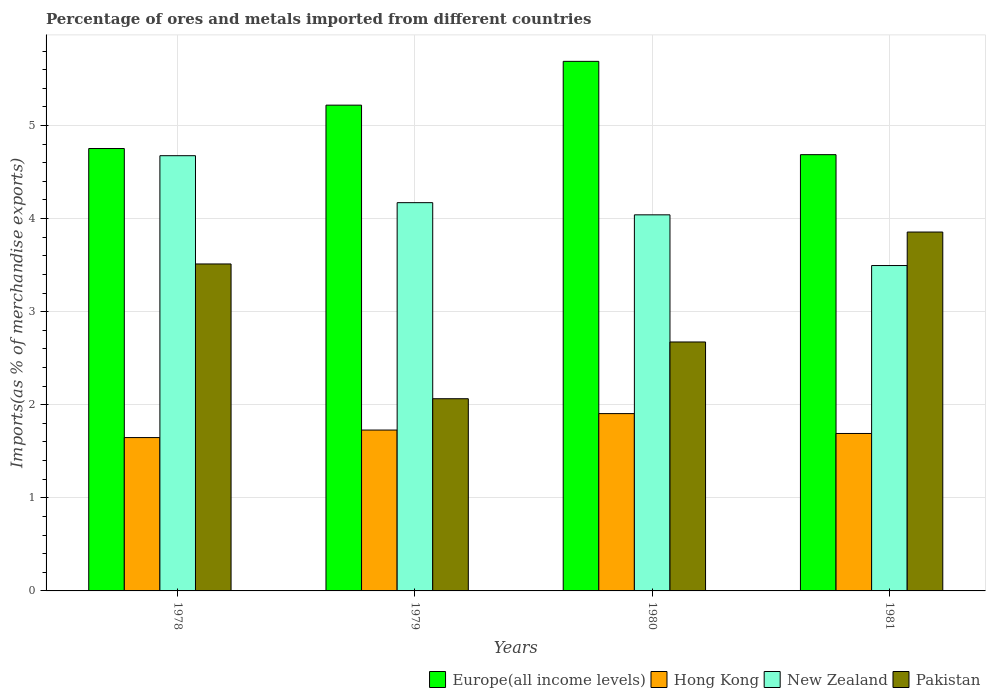How many different coloured bars are there?
Provide a succinct answer. 4. Are the number of bars per tick equal to the number of legend labels?
Keep it short and to the point. Yes. Are the number of bars on each tick of the X-axis equal?
Offer a very short reply. Yes. How many bars are there on the 2nd tick from the left?
Keep it short and to the point. 4. How many bars are there on the 4th tick from the right?
Keep it short and to the point. 4. What is the label of the 3rd group of bars from the left?
Offer a very short reply. 1980. In how many cases, is the number of bars for a given year not equal to the number of legend labels?
Ensure brevity in your answer.  0. What is the percentage of imports to different countries in Europe(all income levels) in 1981?
Your answer should be compact. 4.69. Across all years, what is the maximum percentage of imports to different countries in New Zealand?
Make the answer very short. 4.68. Across all years, what is the minimum percentage of imports to different countries in Pakistan?
Your answer should be very brief. 2.06. In which year was the percentage of imports to different countries in Europe(all income levels) maximum?
Offer a terse response. 1980. In which year was the percentage of imports to different countries in New Zealand minimum?
Offer a terse response. 1981. What is the total percentage of imports to different countries in New Zealand in the graph?
Provide a succinct answer. 16.38. What is the difference between the percentage of imports to different countries in Pakistan in 1979 and that in 1980?
Offer a terse response. -0.61. What is the difference between the percentage of imports to different countries in Europe(all income levels) in 1978 and the percentage of imports to different countries in Hong Kong in 1980?
Provide a short and direct response. 2.85. What is the average percentage of imports to different countries in New Zealand per year?
Keep it short and to the point. 4.1. In the year 1980, what is the difference between the percentage of imports to different countries in Europe(all income levels) and percentage of imports to different countries in Pakistan?
Your answer should be compact. 3.01. In how many years, is the percentage of imports to different countries in Pakistan greater than 5.2 %?
Your answer should be very brief. 0. What is the ratio of the percentage of imports to different countries in Europe(all income levels) in 1979 to that in 1980?
Offer a terse response. 0.92. Is the difference between the percentage of imports to different countries in Europe(all income levels) in 1979 and 1981 greater than the difference between the percentage of imports to different countries in Pakistan in 1979 and 1981?
Give a very brief answer. Yes. What is the difference between the highest and the second highest percentage of imports to different countries in Pakistan?
Provide a short and direct response. 0.34. What is the difference between the highest and the lowest percentage of imports to different countries in Hong Kong?
Your answer should be compact. 0.26. Is the sum of the percentage of imports to different countries in Pakistan in 1978 and 1979 greater than the maximum percentage of imports to different countries in New Zealand across all years?
Your response must be concise. Yes. Is it the case that in every year, the sum of the percentage of imports to different countries in Europe(all income levels) and percentage of imports to different countries in New Zealand is greater than the sum of percentage of imports to different countries in Pakistan and percentage of imports to different countries in Hong Kong?
Keep it short and to the point. Yes. What does the 3rd bar from the right in 1979 represents?
Offer a terse response. Hong Kong. How many bars are there?
Keep it short and to the point. 16. How many years are there in the graph?
Your response must be concise. 4. What is the difference between two consecutive major ticks on the Y-axis?
Keep it short and to the point. 1. Does the graph contain any zero values?
Provide a succinct answer. No. Where does the legend appear in the graph?
Your response must be concise. Bottom right. How are the legend labels stacked?
Ensure brevity in your answer.  Horizontal. What is the title of the graph?
Your response must be concise. Percentage of ores and metals imported from different countries. What is the label or title of the X-axis?
Provide a succinct answer. Years. What is the label or title of the Y-axis?
Offer a terse response. Imports(as % of merchandise exports). What is the Imports(as % of merchandise exports) of Europe(all income levels) in 1978?
Ensure brevity in your answer.  4.75. What is the Imports(as % of merchandise exports) of Hong Kong in 1978?
Offer a very short reply. 1.65. What is the Imports(as % of merchandise exports) of New Zealand in 1978?
Make the answer very short. 4.68. What is the Imports(as % of merchandise exports) of Pakistan in 1978?
Your answer should be very brief. 3.51. What is the Imports(as % of merchandise exports) of Europe(all income levels) in 1979?
Offer a very short reply. 5.22. What is the Imports(as % of merchandise exports) in Hong Kong in 1979?
Your response must be concise. 1.73. What is the Imports(as % of merchandise exports) of New Zealand in 1979?
Offer a terse response. 4.17. What is the Imports(as % of merchandise exports) in Pakistan in 1979?
Keep it short and to the point. 2.06. What is the Imports(as % of merchandise exports) in Europe(all income levels) in 1980?
Give a very brief answer. 5.69. What is the Imports(as % of merchandise exports) in Hong Kong in 1980?
Ensure brevity in your answer.  1.9. What is the Imports(as % of merchandise exports) of New Zealand in 1980?
Your answer should be very brief. 4.04. What is the Imports(as % of merchandise exports) of Pakistan in 1980?
Your response must be concise. 2.67. What is the Imports(as % of merchandise exports) in Europe(all income levels) in 1981?
Your response must be concise. 4.69. What is the Imports(as % of merchandise exports) in Hong Kong in 1981?
Make the answer very short. 1.69. What is the Imports(as % of merchandise exports) in New Zealand in 1981?
Ensure brevity in your answer.  3.5. What is the Imports(as % of merchandise exports) of Pakistan in 1981?
Your answer should be compact. 3.86. Across all years, what is the maximum Imports(as % of merchandise exports) in Europe(all income levels)?
Your answer should be compact. 5.69. Across all years, what is the maximum Imports(as % of merchandise exports) of Hong Kong?
Keep it short and to the point. 1.9. Across all years, what is the maximum Imports(as % of merchandise exports) of New Zealand?
Give a very brief answer. 4.68. Across all years, what is the maximum Imports(as % of merchandise exports) in Pakistan?
Make the answer very short. 3.86. Across all years, what is the minimum Imports(as % of merchandise exports) in Europe(all income levels)?
Offer a terse response. 4.69. Across all years, what is the minimum Imports(as % of merchandise exports) of Hong Kong?
Keep it short and to the point. 1.65. Across all years, what is the minimum Imports(as % of merchandise exports) of New Zealand?
Offer a very short reply. 3.5. Across all years, what is the minimum Imports(as % of merchandise exports) of Pakistan?
Provide a short and direct response. 2.06. What is the total Imports(as % of merchandise exports) in Europe(all income levels) in the graph?
Your answer should be compact. 20.35. What is the total Imports(as % of merchandise exports) of Hong Kong in the graph?
Offer a very short reply. 6.97. What is the total Imports(as % of merchandise exports) of New Zealand in the graph?
Provide a succinct answer. 16.38. What is the total Imports(as % of merchandise exports) in Pakistan in the graph?
Your response must be concise. 12.11. What is the difference between the Imports(as % of merchandise exports) in Europe(all income levels) in 1978 and that in 1979?
Offer a terse response. -0.47. What is the difference between the Imports(as % of merchandise exports) of Hong Kong in 1978 and that in 1979?
Your response must be concise. -0.08. What is the difference between the Imports(as % of merchandise exports) of New Zealand in 1978 and that in 1979?
Your response must be concise. 0.5. What is the difference between the Imports(as % of merchandise exports) of Pakistan in 1978 and that in 1979?
Provide a short and direct response. 1.45. What is the difference between the Imports(as % of merchandise exports) of Europe(all income levels) in 1978 and that in 1980?
Make the answer very short. -0.94. What is the difference between the Imports(as % of merchandise exports) of Hong Kong in 1978 and that in 1980?
Provide a short and direct response. -0.26. What is the difference between the Imports(as % of merchandise exports) in New Zealand in 1978 and that in 1980?
Ensure brevity in your answer.  0.64. What is the difference between the Imports(as % of merchandise exports) of Pakistan in 1978 and that in 1980?
Your response must be concise. 0.84. What is the difference between the Imports(as % of merchandise exports) of Europe(all income levels) in 1978 and that in 1981?
Your answer should be compact. 0.07. What is the difference between the Imports(as % of merchandise exports) of Hong Kong in 1978 and that in 1981?
Offer a very short reply. -0.04. What is the difference between the Imports(as % of merchandise exports) in New Zealand in 1978 and that in 1981?
Your response must be concise. 1.18. What is the difference between the Imports(as % of merchandise exports) of Pakistan in 1978 and that in 1981?
Ensure brevity in your answer.  -0.34. What is the difference between the Imports(as % of merchandise exports) of Europe(all income levels) in 1979 and that in 1980?
Give a very brief answer. -0.47. What is the difference between the Imports(as % of merchandise exports) of Hong Kong in 1979 and that in 1980?
Offer a terse response. -0.18. What is the difference between the Imports(as % of merchandise exports) of New Zealand in 1979 and that in 1980?
Your answer should be compact. 0.13. What is the difference between the Imports(as % of merchandise exports) in Pakistan in 1979 and that in 1980?
Offer a terse response. -0.61. What is the difference between the Imports(as % of merchandise exports) of Europe(all income levels) in 1979 and that in 1981?
Ensure brevity in your answer.  0.53. What is the difference between the Imports(as % of merchandise exports) in Hong Kong in 1979 and that in 1981?
Your response must be concise. 0.04. What is the difference between the Imports(as % of merchandise exports) of New Zealand in 1979 and that in 1981?
Your response must be concise. 0.68. What is the difference between the Imports(as % of merchandise exports) in Pakistan in 1979 and that in 1981?
Your response must be concise. -1.79. What is the difference between the Imports(as % of merchandise exports) of Europe(all income levels) in 1980 and that in 1981?
Give a very brief answer. 1. What is the difference between the Imports(as % of merchandise exports) of Hong Kong in 1980 and that in 1981?
Offer a terse response. 0.21. What is the difference between the Imports(as % of merchandise exports) in New Zealand in 1980 and that in 1981?
Keep it short and to the point. 0.54. What is the difference between the Imports(as % of merchandise exports) in Pakistan in 1980 and that in 1981?
Give a very brief answer. -1.18. What is the difference between the Imports(as % of merchandise exports) of Europe(all income levels) in 1978 and the Imports(as % of merchandise exports) of Hong Kong in 1979?
Offer a terse response. 3.02. What is the difference between the Imports(as % of merchandise exports) in Europe(all income levels) in 1978 and the Imports(as % of merchandise exports) in New Zealand in 1979?
Your answer should be compact. 0.58. What is the difference between the Imports(as % of merchandise exports) in Europe(all income levels) in 1978 and the Imports(as % of merchandise exports) in Pakistan in 1979?
Provide a succinct answer. 2.69. What is the difference between the Imports(as % of merchandise exports) of Hong Kong in 1978 and the Imports(as % of merchandise exports) of New Zealand in 1979?
Provide a succinct answer. -2.52. What is the difference between the Imports(as % of merchandise exports) in Hong Kong in 1978 and the Imports(as % of merchandise exports) in Pakistan in 1979?
Offer a very short reply. -0.42. What is the difference between the Imports(as % of merchandise exports) of New Zealand in 1978 and the Imports(as % of merchandise exports) of Pakistan in 1979?
Give a very brief answer. 2.61. What is the difference between the Imports(as % of merchandise exports) of Europe(all income levels) in 1978 and the Imports(as % of merchandise exports) of Hong Kong in 1980?
Make the answer very short. 2.85. What is the difference between the Imports(as % of merchandise exports) of Europe(all income levels) in 1978 and the Imports(as % of merchandise exports) of New Zealand in 1980?
Your answer should be very brief. 0.71. What is the difference between the Imports(as % of merchandise exports) of Europe(all income levels) in 1978 and the Imports(as % of merchandise exports) of Pakistan in 1980?
Your response must be concise. 2.08. What is the difference between the Imports(as % of merchandise exports) in Hong Kong in 1978 and the Imports(as % of merchandise exports) in New Zealand in 1980?
Provide a succinct answer. -2.39. What is the difference between the Imports(as % of merchandise exports) of Hong Kong in 1978 and the Imports(as % of merchandise exports) of Pakistan in 1980?
Give a very brief answer. -1.03. What is the difference between the Imports(as % of merchandise exports) of New Zealand in 1978 and the Imports(as % of merchandise exports) of Pakistan in 1980?
Ensure brevity in your answer.  2. What is the difference between the Imports(as % of merchandise exports) in Europe(all income levels) in 1978 and the Imports(as % of merchandise exports) in Hong Kong in 1981?
Offer a very short reply. 3.06. What is the difference between the Imports(as % of merchandise exports) of Europe(all income levels) in 1978 and the Imports(as % of merchandise exports) of New Zealand in 1981?
Provide a succinct answer. 1.26. What is the difference between the Imports(as % of merchandise exports) in Europe(all income levels) in 1978 and the Imports(as % of merchandise exports) in Pakistan in 1981?
Offer a very short reply. 0.9. What is the difference between the Imports(as % of merchandise exports) of Hong Kong in 1978 and the Imports(as % of merchandise exports) of New Zealand in 1981?
Give a very brief answer. -1.85. What is the difference between the Imports(as % of merchandise exports) in Hong Kong in 1978 and the Imports(as % of merchandise exports) in Pakistan in 1981?
Offer a very short reply. -2.21. What is the difference between the Imports(as % of merchandise exports) of New Zealand in 1978 and the Imports(as % of merchandise exports) of Pakistan in 1981?
Give a very brief answer. 0.82. What is the difference between the Imports(as % of merchandise exports) in Europe(all income levels) in 1979 and the Imports(as % of merchandise exports) in Hong Kong in 1980?
Your answer should be very brief. 3.31. What is the difference between the Imports(as % of merchandise exports) of Europe(all income levels) in 1979 and the Imports(as % of merchandise exports) of New Zealand in 1980?
Keep it short and to the point. 1.18. What is the difference between the Imports(as % of merchandise exports) of Europe(all income levels) in 1979 and the Imports(as % of merchandise exports) of Pakistan in 1980?
Keep it short and to the point. 2.54. What is the difference between the Imports(as % of merchandise exports) of Hong Kong in 1979 and the Imports(as % of merchandise exports) of New Zealand in 1980?
Provide a succinct answer. -2.31. What is the difference between the Imports(as % of merchandise exports) of Hong Kong in 1979 and the Imports(as % of merchandise exports) of Pakistan in 1980?
Keep it short and to the point. -0.95. What is the difference between the Imports(as % of merchandise exports) of New Zealand in 1979 and the Imports(as % of merchandise exports) of Pakistan in 1980?
Your response must be concise. 1.5. What is the difference between the Imports(as % of merchandise exports) in Europe(all income levels) in 1979 and the Imports(as % of merchandise exports) in Hong Kong in 1981?
Make the answer very short. 3.53. What is the difference between the Imports(as % of merchandise exports) of Europe(all income levels) in 1979 and the Imports(as % of merchandise exports) of New Zealand in 1981?
Offer a terse response. 1.72. What is the difference between the Imports(as % of merchandise exports) in Europe(all income levels) in 1979 and the Imports(as % of merchandise exports) in Pakistan in 1981?
Keep it short and to the point. 1.36. What is the difference between the Imports(as % of merchandise exports) of Hong Kong in 1979 and the Imports(as % of merchandise exports) of New Zealand in 1981?
Keep it short and to the point. -1.77. What is the difference between the Imports(as % of merchandise exports) in Hong Kong in 1979 and the Imports(as % of merchandise exports) in Pakistan in 1981?
Your response must be concise. -2.13. What is the difference between the Imports(as % of merchandise exports) in New Zealand in 1979 and the Imports(as % of merchandise exports) in Pakistan in 1981?
Provide a succinct answer. 0.32. What is the difference between the Imports(as % of merchandise exports) in Europe(all income levels) in 1980 and the Imports(as % of merchandise exports) in Hong Kong in 1981?
Ensure brevity in your answer.  4. What is the difference between the Imports(as % of merchandise exports) in Europe(all income levels) in 1980 and the Imports(as % of merchandise exports) in New Zealand in 1981?
Your answer should be very brief. 2.19. What is the difference between the Imports(as % of merchandise exports) in Europe(all income levels) in 1980 and the Imports(as % of merchandise exports) in Pakistan in 1981?
Give a very brief answer. 1.83. What is the difference between the Imports(as % of merchandise exports) in Hong Kong in 1980 and the Imports(as % of merchandise exports) in New Zealand in 1981?
Your answer should be very brief. -1.59. What is the difference between the Imports(as % of merchandise exports) in Hong Kong in 1980 and the Imports(as % of merchandise exports) in Pakistan in 1981?
Provide a succinct answer. -1.95. What is the difference between the Imports(as % of merchandise exports) of New Zealand in 1980 and the Imports(as % of merchandise exports) of Pakistan in 1981?
Keep it short and to the point. 0.18. What is the average Imports(as % of merchandise exports) in Europe(all income levels) per year?
Give a very brief answer. 5.09. What is the average Imports(as % of merchandise exports) of Hong Kong per year?
Offer a terse response. 1.74. What is the average Imports(as % of merchandise exports) in New Zealand per year?
Provide a succinct answer. 4.1. What is the average Imports(as % of merchandise exports) in Pakistan per year?
Your answer should be compact. 3.03. In the year 1978, what is the difference between the Imports(as % of merchandise exports) of Europe(all income levels) and Imports(as % of merchandise exports) of Hong Kong?
Your answer should be compact. 3.1. In the year 1978, what is the difference between the Imports(as % of merchandise exports) of Europe(all income levels) and Imports(as % of merchandise exports) of New Zealand?
Keep it short and to the point. 0.08. In the year 1978, what is the difference between the Imports(as % of merchandise exports) of Europe(all income levels) and Imports(as % of merchandise exports) of Pakistan?
Give a very brief answer. 1.24. In the year 1978, what is the difference between the Imports(as % of merchandise exports) in Hong Kong and Imports(as % of merchandise exports) in New Zealand?
Ensure brevity in your answer.  -3.03. In the year 1978, what is the difference between the Imports(as % of merchandise exports) of Hong Kong and Imports(as % of merchandise exports) of Pakistan?
Your answer should be compact. -1.86. In the year 1978, what is the difference between the Imports(as % of merchandise exports) in New Zealand and Imports(as % of merchandise exports) in Pakistan?
Keep it short and to the point. 1.16. In the year 1979, what is the difference between the Imports(as % of merchandise exports) of Europe(all income levels) and Imports(as % of merchandise exports) of Hong Kong?
Make the answer very short. 3.49. In the year 1979, what is the difference between the Imports(as % of merchandise exports) in Europe(all income levels) and Imports(as % of merchandise exports) in New Zealand?
Keep it short and to the point. 1.05. In the year 1979, what is the difference between the Imports(as % of merchandise exports) in Europe(all income levels) and Imports(as % of merchandise exports) in Pakistan?
Keep it short and to the point. 3.15. In the year 1979, what is the difference between the Imports(as % of merchandise exports) in Hong Kong and Imports(as % of merchandise exports) in New Zealand?
Make the answer very short. -2.44. In the year 1979, what is the difference between the Imports(as % of merchandise exports) of Hong Kong and Imports(as % of merchandise exports) of Pakistan?
Offer a very short reply. -0.34. In the year 1979, what is the difference between the Imports(as % of merchandise exports) in New Zealand and Imports(as % of merchandise exports) in Pakistan?
Offer a terse response. 2.11. In the year 1980, what is the difference between the Imports(as % of merchandise exports) in Europe(all income levels) and Imports(as % of merchandise exports) in Hong Kong?
Offer a very short reply. 3.78. In the year 1980, what is the difference between the Imports(as % of merchandise exports) in Europe(all income levels) and Imports(as % of merchandise exports) in New Zealand?
Your response must be concise. 1.65. In the year 1980, what is the difference between the Imports(as % of merchandise exports) of Europe(all income levels) and Imports(as % of merchandise exports) of Pakistan?
Your response must be concise. 3.01. In the year 1980, what is the difference between the Imports(as % of merchandise exports) in Hong Kong and Imports(as % of merchandise exports) in New Zealand?
Make the answer very short. -2.14. In the year 1980, what is the difference between the Imports(as % of merchandise exports) of Hong Kong and Imports(as % of merchandise exports) of Pakistan?
Ensure brevity in your answer.  -0.77. In the year 1980, what is the difference between the Imports(as % of merchandise exports) in New Zealand and Imports(as % of merchandise exports) in Pakistan?
Make the answer very short. 1.37. In the year 1981, what is the difference between the Imports(as % of merchandise exports) in Europe(all income levels) and Imports(as % of merchandise exports) in Hong Kong?
Provide a short and direct response. 3. In the year 1981, what is the difference between the Imports(as % of merchandise exports) of Europe(all income levels) and Imports(as % of merchandise exports) of New Zealand?
Your response must be concise. 1.19. In the year 1981, what is the difference between the Imports(as % of merchandise exports) in Europe(all income levels) and Imports(as % of merchandise exports) in Pakistan?
Provide a short and direct response. 0.83. In the year 1981, what is the difference between the Imports(as % of merchandise exports) in Hong Kong and Imports(as % of merchandise exports) in New Zealand?
Your answer should be compact. -1.8. In the year 1981, what is the difference between the Imports(as % of merchandise exports) of Hong Kong and Imports(as % of merchandise exports) of Pakistan?
Give a very brief answer. -2.16. In the year 1981, what is the difference between the Imports(as % of merchandise exports) of New Zealand and Imports(as % of merchandise exports) of Pakistan?
Your response must be concise. -0.36. What is the ratio of the Imports(as % of merchandise exports) of Europe(all income levels) in 1978 to that in 1979?
Offer a very short reply. 0.91. What is the ratio of the Imports(as % of merchandise exports) of Hong Kong in 1978 to that in 1979?
Make the answer very short. 0.95. What is the ratio of the Imports(as % of merchandise exports) in New Zealand in 1978 to that in 1979?
Offer a very short reply. 1.12. What is the ratio of the Imports(as % of merchandise exports) in Pakistan in 1978 to that in 1979?
Keep it short and to the point. 1.7. What is the ratio of the Imports(as % of merchandise exports) in Europe(all income levels) in 1978 to that in 1980?
Make the answer very short. 0.84. What is the ratio of the Imports(as % of merchandise exports) of Hong Kong in 1978 to that in 1980?
Make the answer very short. 0.86. What is the ratio of the Imports(as % of merchandise exports) of New Zealand in 1978 to that in 1980?
Your answer should be very brief. 1.16. What is the ratio of the Imports(as % of merchandise exports) in Pakistan in 1978 to that in 1980?
Provide a succinct answer. 1.31. What is the ratio of the Imports(as % of merchandise exports) in Hong Kong in 1978 to that in 1981?
Provide a short and direct response. 0.97. What is the ratio of the Imports(as % of merchandise exports) in New Zealand in 1978 to that in 1981?
Keep it short and to the point. 1.34. What is the ratio of the Imports(as % of merchandise exports) of Pakistan in 1978 to that in 1981?
Provide a short and direct response. 0.91. What is the ratio of the Imports(as % of merchandise exports) of Europe(all income levels) in 1979 to that in 1980?
Your response must be concise. 0.92. What is the ratio of the Imports(as % of merchandise exports) in Hong Kong in 1979 to that in 1980?
Keep it short and to the point. 0.91. What is the ratio of the Imports(as % of merchandise exports) in New Zealand in 1979 to that in 1980?
Give a very brief answer. 1.03. What is the ratio of the Imports(as % of merchandise exports) in Pakistan in 1979 to that in 1980?
Your response must be concise. 0.77. What is the ratio of the Imports(as % of merchandise exports) in Europe(all income levels) in 1979 to that in 1981?
Provide a short and direct response. 1.11. What is the ratio of the Imports(as % of merchandise exports) in Hong Kong in 1979 to that in 1981?
Your answer should be compact. 1.02. What is the ratio of the Imports(as % of merchandise exports) in New Zealand in 1979 to that in 1981?
Offer a very short reply. 1.19. What is the ratio of the Imports(as % of merchandise exports) in Pakistan in 1979 to that in 1981?
Offer a terse response. 0.54. What is the ratio of the Imports(as % of merchandise exports) in Europe(all income levels) in 1980 to that in 1981?
Give a very brief answer. 1.21. What is the ratio of the Imports(as % of merchandise exports) of Hong Kong in 1980 to that in 1981?
Provide a succinct answer. 1.13. What is the ratio of the Imports(as % of merchandise exports) of New Zealand in 1980 to that in 1981?
Your answer should be compact. 1.16. What is the ratio of the Imports(as % of merchandise exports) of Pakistan in 1980 to that in 1981?
Offer a terse response. 0.69. What is the difference between the highest and the second highest Imports(as % of merchandise exports) in Europe(all income levels)?
Offer a terse response. 0.47. What is the difference between the highest and the second highest Imports(as % of merchandise exports) in Hong Kong?
Make the answer very short. 0.18. What is the difference between the highest and the second highest Imports(as % of merchandise exports) of New Zealand?
Give a very brief answer. 0.5. What is the difference between the highest and the second highest Imports(as % of merchandise exports) in Pakistan?
Make the answer very short. 0.34. What is the difference between the highest and the lowest Imports(as % of merchandise exports) of Hong Kong?
Your answer should be compact. 0.26. What is the difference between the highest and the lowest Imports(as % of merchandise exports) in New Zealand?
Provide a short and direct response. 1.18. What is the difference between the highest and the lowest Imports(as % of merchandise exports) of Pakistan?
Keep it short and to the point. 1.79. 